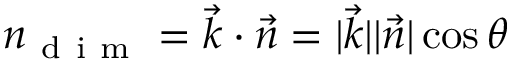<formula> <loc_0><loc_0><loc_500><loc_500>n _ { d i m } = \vec { k } \cdot \vec { n } = | \vec { k } | | \vec { n } | \cos \theta</formula> 